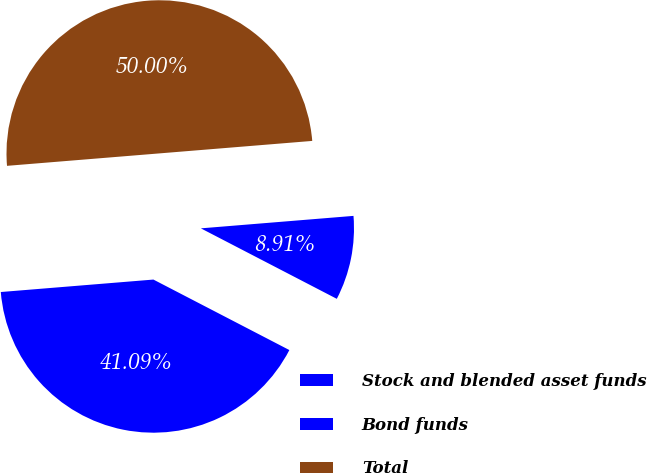<chart> <loc_0><loc_0><loc_500><loc_500><pie_chart><fcel>Stock and blended asset funds<fcel>Bond funds<fcel>Total<nl><fcel>41.09%<fcel>8.91%<fcel>50.0%<nl></chart> 